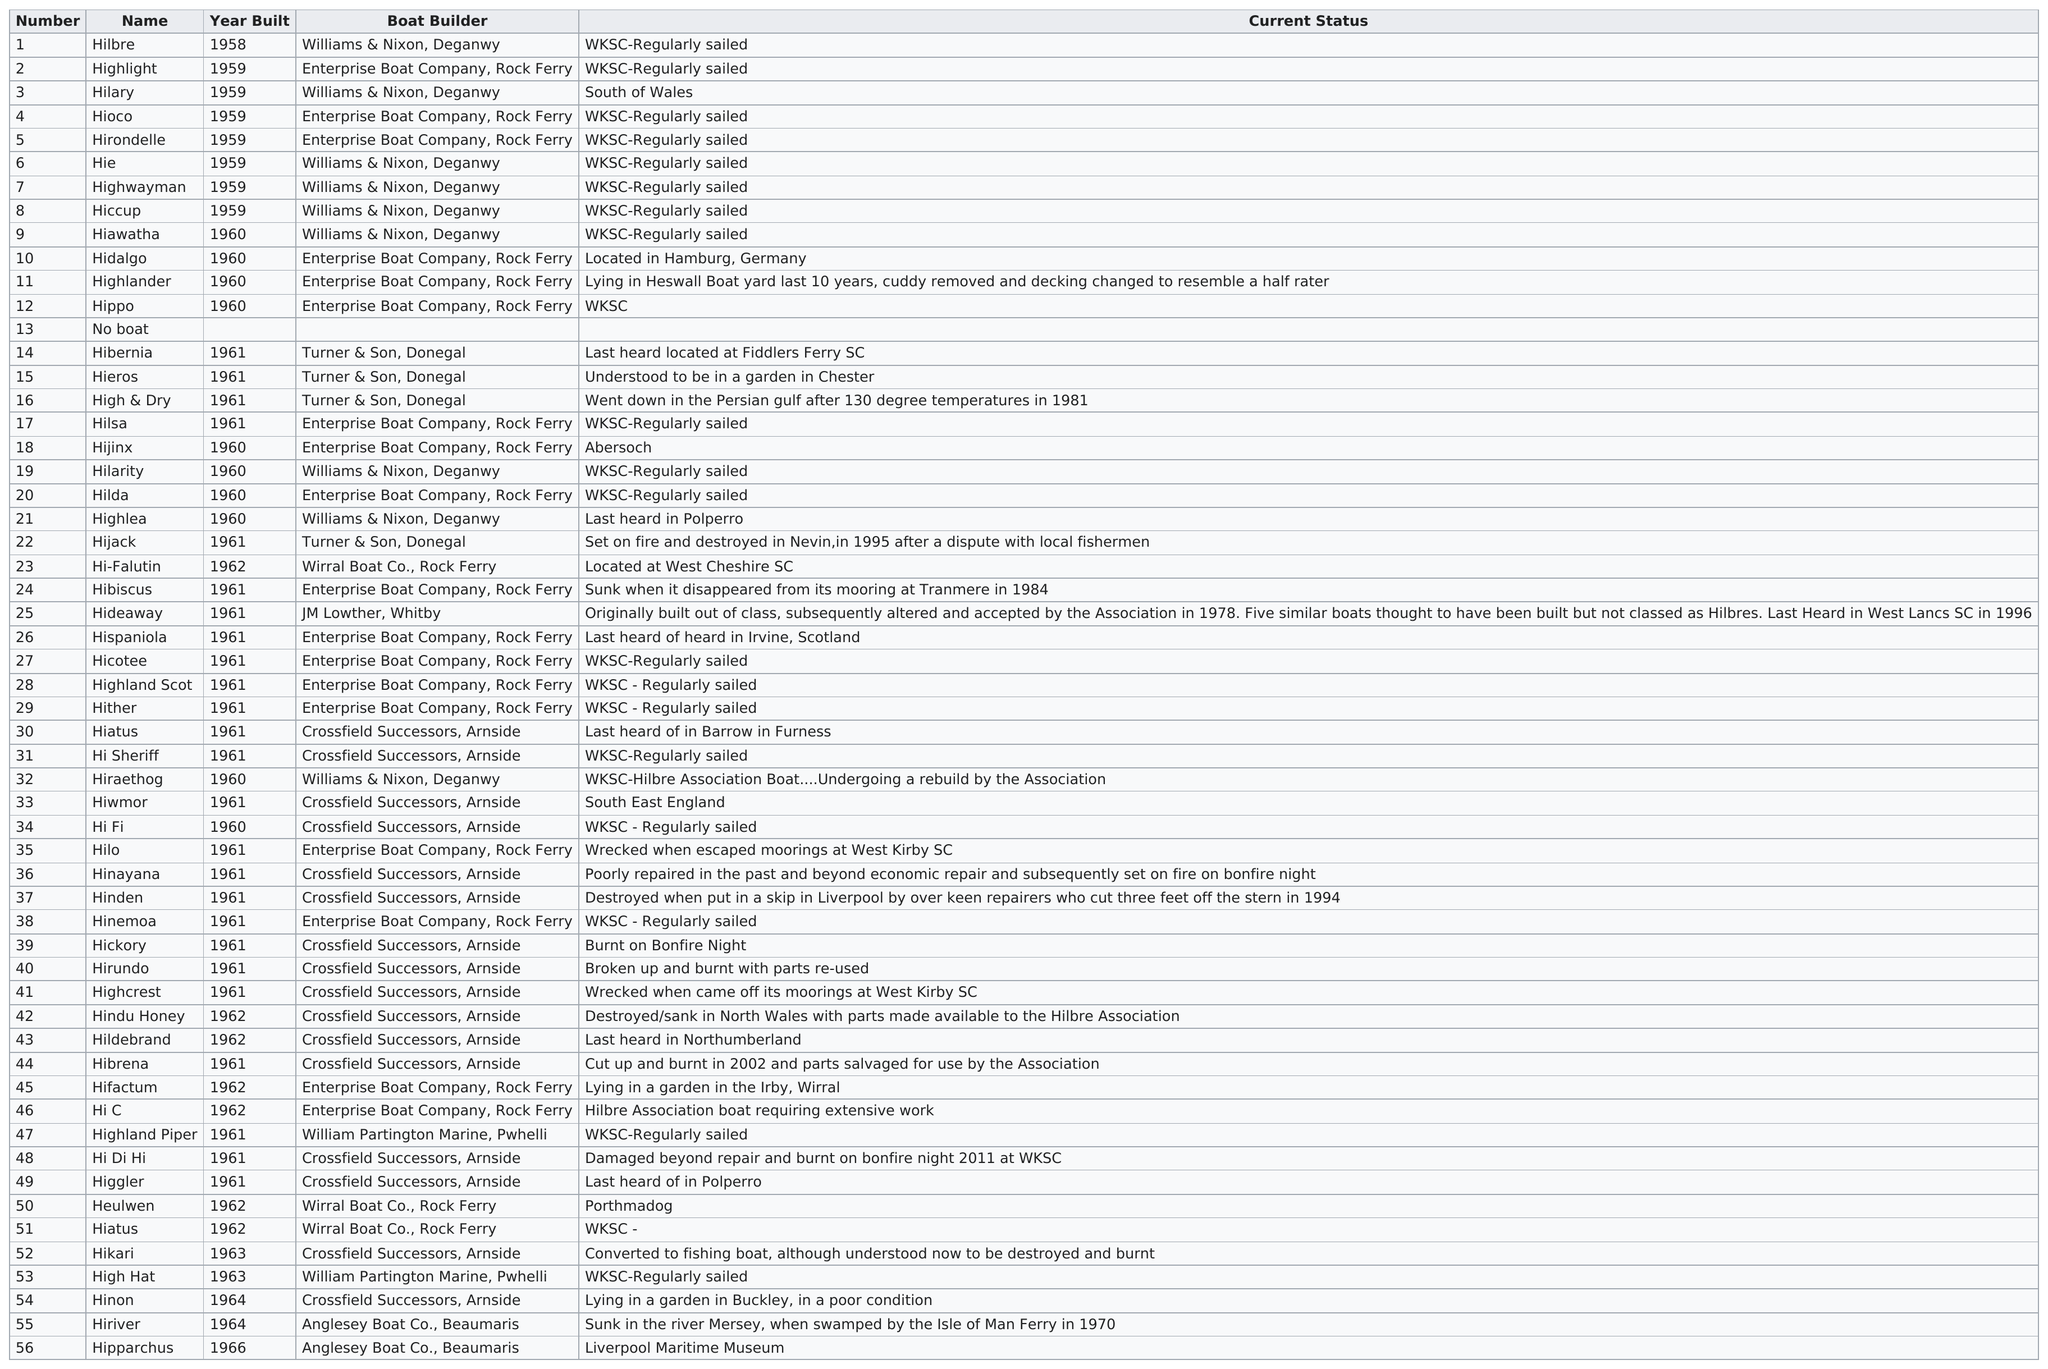Identify some key points in this picture. Hilbre Island One Design Keelboats were first built in 1958. The Highlander has been lying in Heswall Boat Yard for 10 years, according to the table. The hippopotamus and the hijack are not the same in age, with the hippopotamus being older than the hijack by one year. From 1958 to 1962, a total of 51 keelboats were constructed. The boat builder who created the Hie after the Hirondelle was Williams & Nixon, located in Deganwy. 